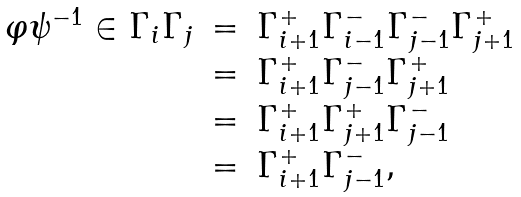<formula> <loc_0><loc_0><loc_500><loc_500>\begin{array} { l l l } \varphi \psi ^ { - 1 } \in \Gamma _ { i } \Gamma _ { j } & = & \Gamma _ { i + 1 } ^ { + } \Gamma _ { i - 1 } ^ { - } \Gamma _ { j - 1 } ^ { - } \Gamma _ { j + 1 } ^ { + } \\ & = & \Gamma _ { i + 1 } ^ { + } \Gamma _ { j - 1 } ^ { - } \Gamma _ { j + 1 } ^ { + } \\ & = & \Gamma _ { i + 1 } ^ { + } \Gamma _ { j + 1 } ^ { + } \Gamma _ { j - 1 } ^ { - } \\ & = & \Gamma _ { i + 1 } ^ { + } \Gamma _ { j - 1 } ^ { - } , \end{array}</formula> 